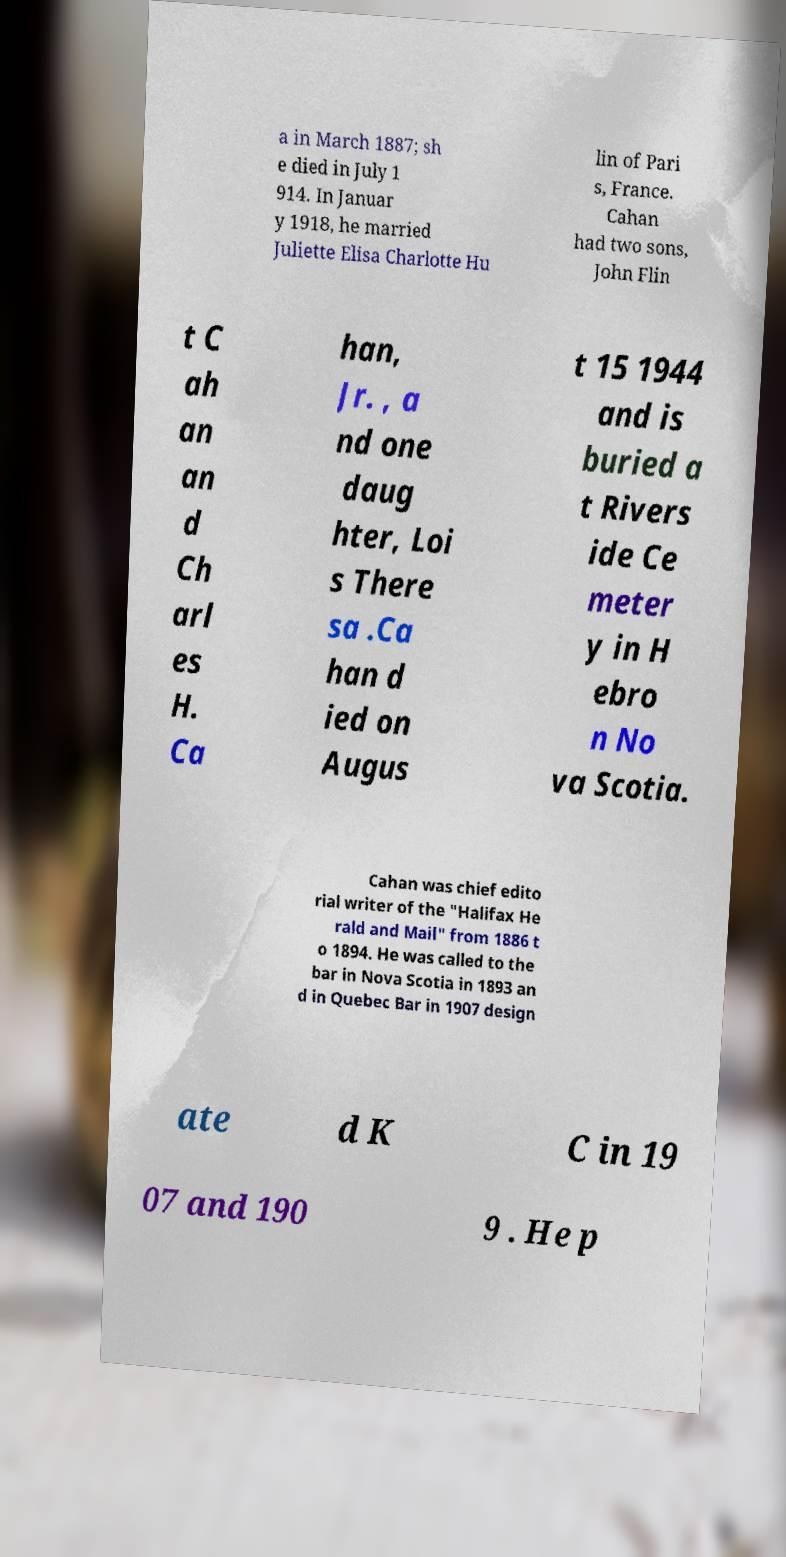Please identify and transcribe the text found in this image. a in March 1887; sh e died in July 1 914. In Januar y 1918, he married Juliette Elisa Charlotte Hu lin of Pari s, France. Cahan had two sons, John Flin t C ah an an d Ch arl es H. Ca han, Jr. , a nd one daug hter, Loi s There sa .Ca han d ied on Augus t 15 1944 and is buried a t Rivers ide Ce meter y in H ebro n No va Scotia. Cahan was chief edito rial writer of the "Halifax He rald and Mail" from 1886 t o 1894. He was called to the bar in Nova Scotia in 1893 an d in Quebec Bar in 1907 design ate d K C in 19 07 and 190 9 . He p 